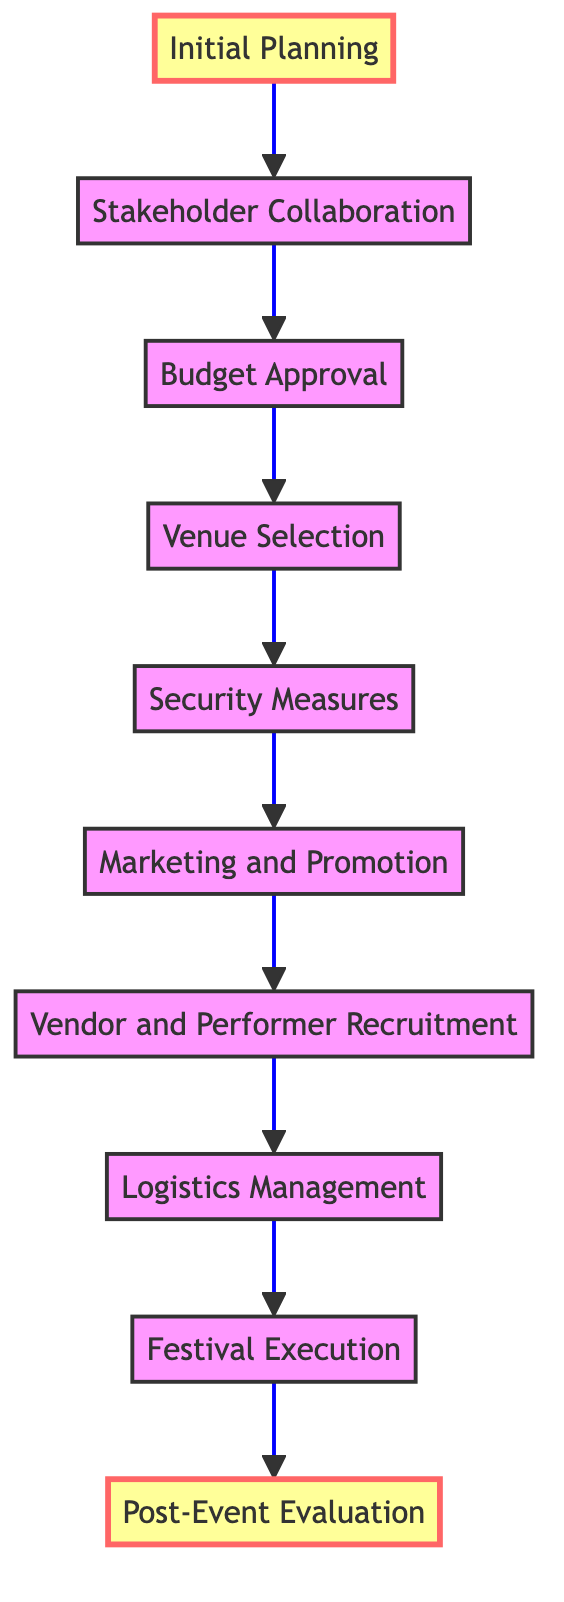What is the final step in the process? The diagram indicates that the last step after all festival activities is "Post-Event Evaluation," which is where success is measured and feedback is gathered.
Answer: Post-Event Evaluation How many steps are in the process? The diagram lists ten distinct steps from "Initial Planning" to "Post-Event Evaluation," indicating the number of process stages necessary for organizing the festival.
Answer: Ten What comes after "Security Measures"? The flowchart shows that the next step following "Security Measures" is "Marketing and Promotion," indicating the progression of tasks leading to the festival.
Answer: Marketing and Promotion Which organization is involved in the "Budget Approval" step? The diagram specifies that the "Finance Ministry" is the organization engaged in the "Budget Approval" step, responsible for funding allocation for the festival.
Answer: Finance Ministry At what stage is vendor recruitment conducted? According to the flowchart, "Vendor and Performer Recruitment" takes place after "Marketing and Promotion," showing the sequence for recruiting necessary participants for the festival.
Answer: Vendor and Performer Recruitment How many nodes lead into the "Festival Execution" step? In the flowchart, there is one direct preceding step leading into "Festival Execution," which is "Logistics Management," indicating a single path into executing the festival.
Answer: One In which step do stakeholders collaborate? The flowchart indicates that "Stakeholder Collaboration" occurs right after "Initial Planning," where engagement with the Russian Orthodox Church and other authorities takes place.
Answer: Stakeholder Collaboration Which step requires identifying suitable venues? The diagram clearly states that "Venue Selection" is the process in which suitable venues for festival activities must be determined and secured.
Answer: Venue Selection What is the purpose of "Post-Event Evaluation"? The diagram highlights that "Post-Event Evaluation" allows for a review and collection of feedback to assess the overall success of the festival and improvements needed.
Answer: Review and feedback collection 